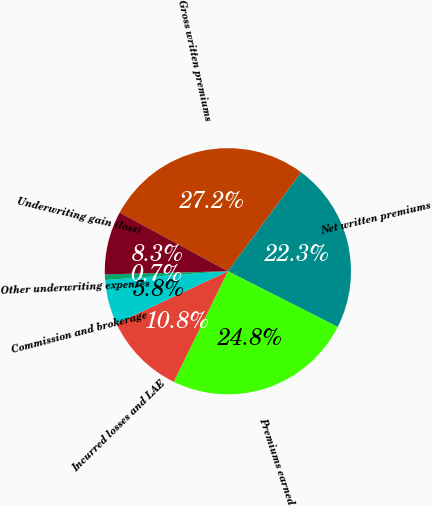Convert chart to OTSL. <chart><loc_0><loc_0><loc_500><loc_500><pie_chart><fcel>Gross written premiums<fcel>Net written premiums<fcel>Premiums earned<fcel>Incurred losses and LAE<fcel>Commission and brokerage<fcel>Other underwriting expenses<fcel>Underwriting gain (loss)<nl><fcel>27.25%<fcel>22.32%<fcel>24.78%<fcel>10.77%<fcel>5.84%<fcel>0.73%<fcel>8.31%<nl></chart> 